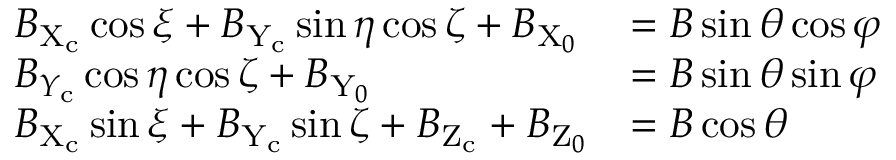<formula> <loc_0><loc_0><loc_500><loc_500>\begin{array} { l l } { B _ { X _ { c } } \cos \xi + B _ { Y _ { c } } \sin \eta \cos \zeta + B _ { X _ { 0 } } } & { = B \sin \theta \cos \varphi } \\ { B _ { Y _ { c } } \cos \eta \cos \zeta + B _ { Y _ { 0 } } } & { = B \sin \theta \sin \varphi } \\ { B _ { X _ { c } } \sin \xi + B _ { Y _ { c } } \sin \zeta + B _ { Z _ { c } } + B _ { Z _ { 0 } } } & { = B \cos \theta } \end{array}</formula> 